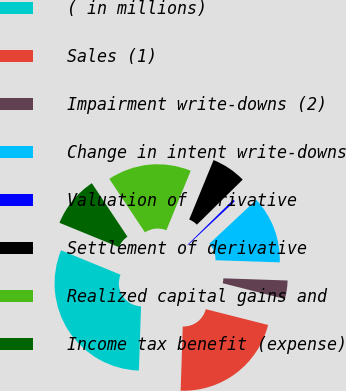<chart> <loc_0><loc_0><loc_500><loc_500><pie_chart><fcel>( in millions)<fcel>Sales (1)<fcel>Impairment write-downs (2)<fcel>Change in intent write-downs<fcel>Valuation of derivative<fcel>Settlement of derivative<fcel>Realized capital gains and<fcel>Income tax benefit (expense)<nl><fcel>30.65%<fcel>21.58%<fcel>3.42%<fcel>12.5%<fcel>0.4%<fcel>6.45%<fcel>15.53%<fcel>9.47%<nl></chart> 